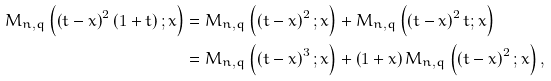Convert formula to latex. <formula><loc_0><loc_0><loc_500><loc_500>M _ { n , q } \left ( \left ( t - x \right ) ^ { 2 } \left ( 1 + t \right ) ; x \right ) & = M _ { n , q } \left ( \left ( t - x \right ) ^ { 2 } ; x \right ) + M _ { n , q } \left ( \left ( t - x \right ) ^ { 2 } t ; x \right ) \\ & = M _ { n , q } \left ( \left ( t - x \right ) ^ { 3 } ; x \right ) + \left ( 1 + x \right ) M _ { n , q } \left ( \left ( t - x \right ) ^ { 2 } ; x \right ) ,</formula> 